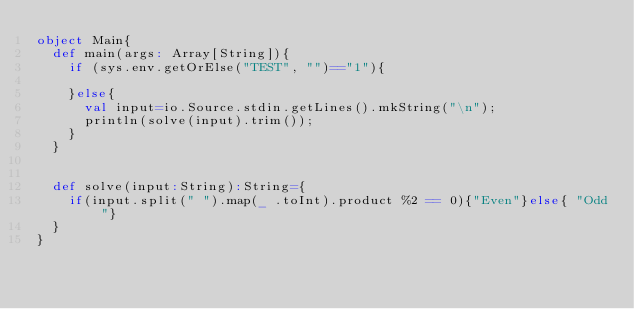<code> <loc_0><loc_0><loc_500><loc_500><_Scala_>object Main{
  def main(args: Array[String]){
    if (sys.env.getOrElse("TEST", "")=="1"){

    }else{
      val input=io.Source.stdin.getLines().mkString("\n");
      println(solve(input).trim());
    }
  }


  def solve(input:String):String={
    if(input.split(" ").map(_ .toInt).product %2 == 0){"Even"}else{ "Odd"}
  }
}</code> 